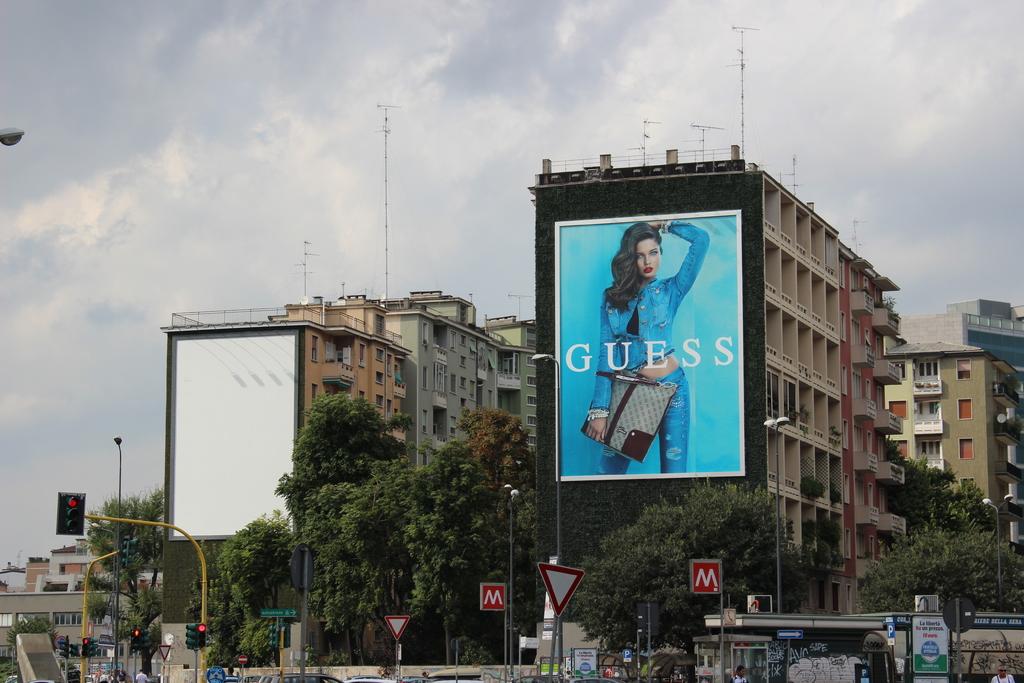What brand is on the sign?
Make the answer very short. Guess. What letter is on the red signs?
Provide a short and direct response. M. 